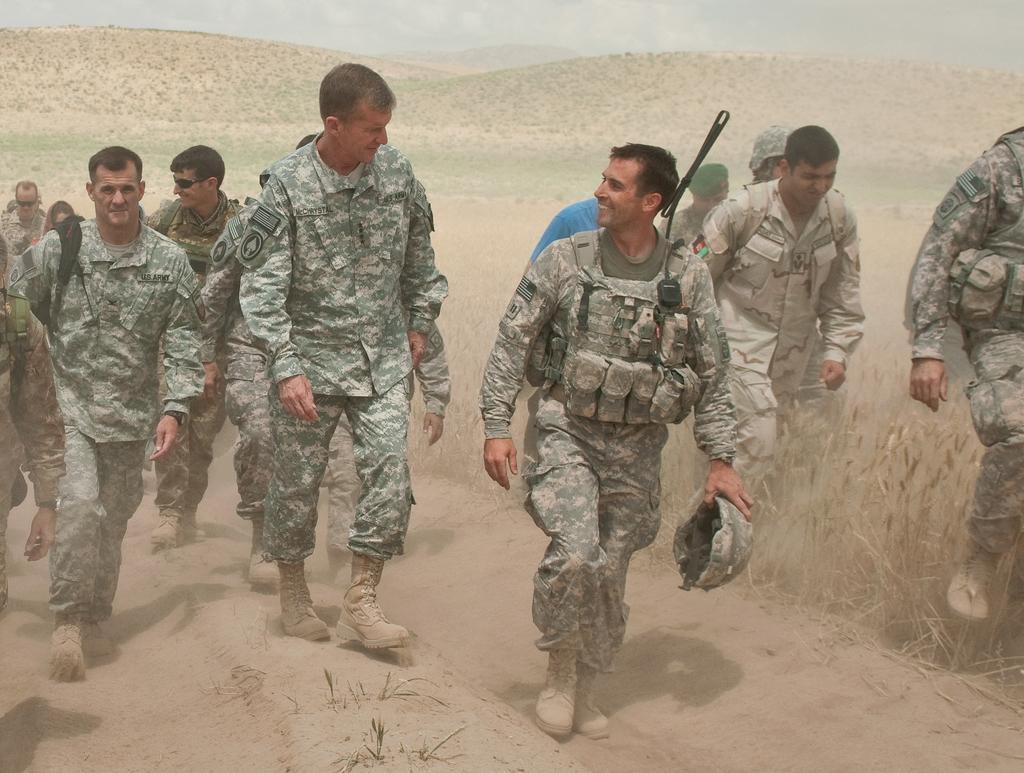How would you summarize this image in a sentence or two? This picture consists of army soldiers those who are walking on the right and left side of the image and there is greenery in the background area of the image. 